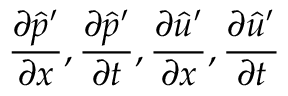Convert formula to latex. <formula><loc_0><loc_0><loc_500><loc_500>\frac { \partial \hat { p } ^ { \prime } } { \partial x } , \frac { \partial \hat { p } ^ { \prime } } { \partial t } , \frac { \partial \hat { u } ^ { \prime } } { \partial x } , \frac { \partial \hat { u } ^ { \prime } } { \partial t }</formula> 